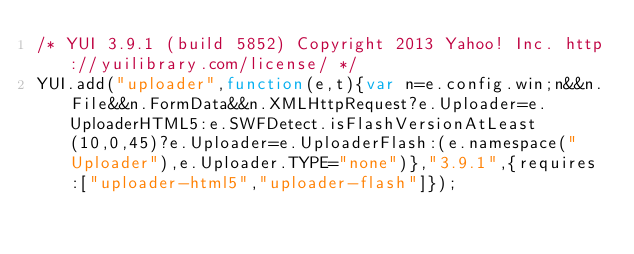Convert code to text. <code><loc_0><loc_0><loc_500><loc_500><_JavaScript_>/* YUI 3.9.1 (build 5852) Copyright 2013 Yahoo! Inc. http://yuilibrary.com/license/ */
YUI.add("uploader",function(e,t){var n=e.config.win;n&&n.File&&n.FormData&&n.XMLHttpRequest?e.Uploader=e.UploaderHTML5:e.SWFDetect.isFlashVersionAtLeast(10,0,45)?e.Uploader=e.UploaderFlash:(e.namespace("Uploader"),e.Uploader.TYPE="none")},"3.9.1",{requires:["uploader-html5","uploader-flash"]});
</code> 